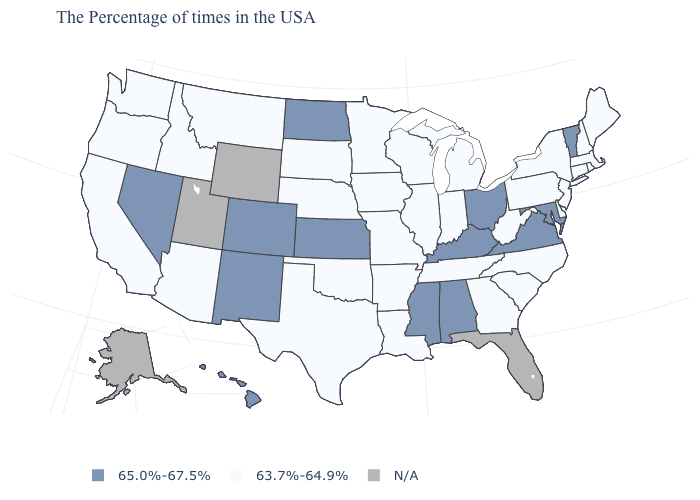What is the value of Connecticut?
Quick response, please. 63.7%-64.9%. Which states have the highest value in the USA?
Keep it brief. Vermont, Maryland, Virginia, Ohio, Kentucky, Alabama, Mississippi, Kansas, North Dakota, Colorado, New Mexico, Nevada, Hawaii. Does the first symbol in the legend represent the smallest category?
Short answer required. No. What is the value of New York?
Short answer required. 63.7%-64.9%. Which states hav the highest value in the West?
Keep it brief. Colorado, New Mexico, Nevada, Hawaii. Name the states that have a value in the range N/A?
Answer briefly. Florida, Wyoming, Utah, Alaska. Among the states that border Kansas , which have the lowest value?
Give a very brief answer. Missouri, Nebraska, Oklahoma. What is the value of Michigan?
Write a very short answer. 63.7%-64.9%. What is the highest value in states that border California?
Give a very brief answer. 65.0%-67.5%. Name the states that have a value in the range 63.7%-64.9%?
Quick response, please. Maine, Massachusetts, Rhode Island, New Hampshire, Connecticut, New York, New Jersey, Delaware, Pennsylvania, North Carolina, South Carolina, West Virginia, Georgia, Michigan, Indiana, Tennessee, Wisconsin, Illinois, Louisiana, Missouri, Arkansas, Minnesota, Iowa, Nebraska, Oklahoma, Texas, South Dakota, Montana, Arizona, Idaho, California, Washington, Oregon. What is the highest value in states that border Washington?
Write a very short answer. 63.7%-64.9%. Name the states that have a value in the range N/A?
Be succinct. Florida, Wyoming, Utah, Alaska. How many symbols are there in the legend?
Short answer required. 3. What is the lowest value in states that border South Dakota?
Keep it brief. 63.7%-64.9%. 